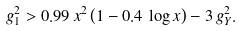<formula> <loc_0><loc_0><loc_500><loc_500>g _ { 1 } ^ { 2 } > 0 . 9 9 \, x ^ { 2 } \left ( 1 - 0 . 4 \, \log { x } \right ) - 3 \, g _ { Y } ^ { 2 } .</formula> 